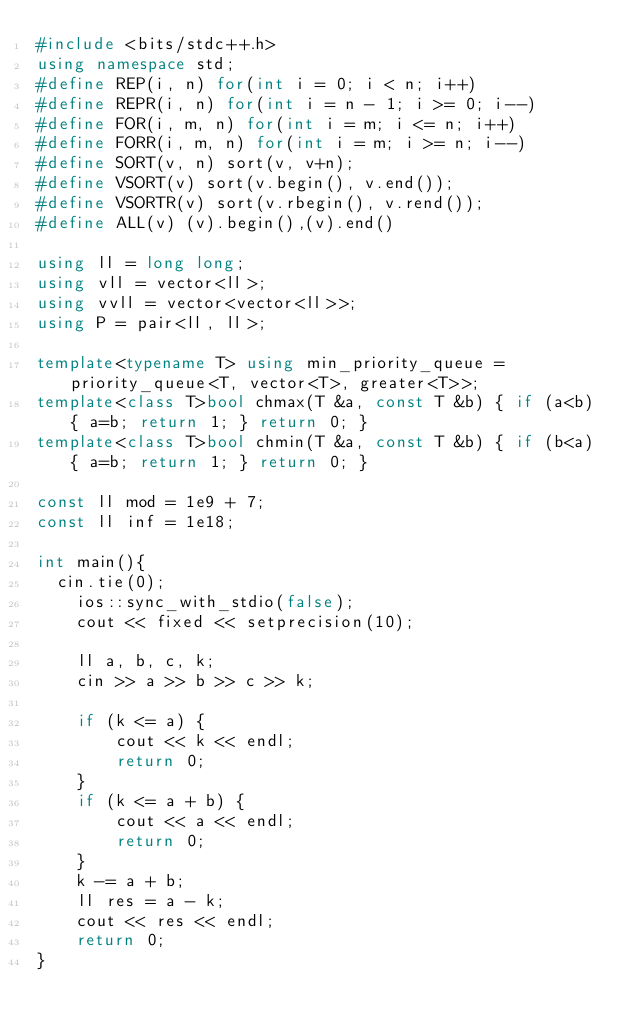<code> <loc_0><loc_0><loc_500><loc_500><_C++_>#include <bits/stdc++.h>
using namespace std;
#define REP(i, n) for(int i = 0; i < n; i++)
#define REPR(i, n) for(int i = n - 1; i >= 0; i--)
#define FOR(i, m, n) for(int i = m; i <= n; i++)
#define FORR(i, m, n) for(int i = m; i >= n; i--)
#define SORT(v, n) sort(v, v+n);
#define VSORT(v) sort(v.begin(), v.end());
#define VSORTR(v) sort(v.rbegin(), v.rend());
#define ALL(v) (v).begin(),(v).end()
 
using ll = long long;
using vll = vector<ll>;
using vvll = vector<vector<ll>>;
using P = pair<ll, ll>;

template<typename T> using min_priority_queue = priority_queue<T, vector<T>, greater<T>>;
template<class T>bool chmax(T &a, const T &b) { if (a<b) { a=b; return 1; } return 0; }
template<class T>bool chmin(T &a, const T &b) { if (b<a) { a=b; return 1; } return 0; }

const ll mod = 1e9 + 7;
const ll inf = 1e18;

int main(){
	cin.tie(0);
    ios::sync_with_stdio(false);
    cout << fixed << setprecision(10);

    ll a, b, c, k;
    cin >> a >> b >> c >> k;

    if (k <= a) {
        cout << k << endl;
        return 0;
    }
    if (k <= a + b) {
        cout << a << endl;
        return 0;
    }
    k -= a + b;
    ll res = a - k;
    cout << res << endl;
    return 0;
}</code> 